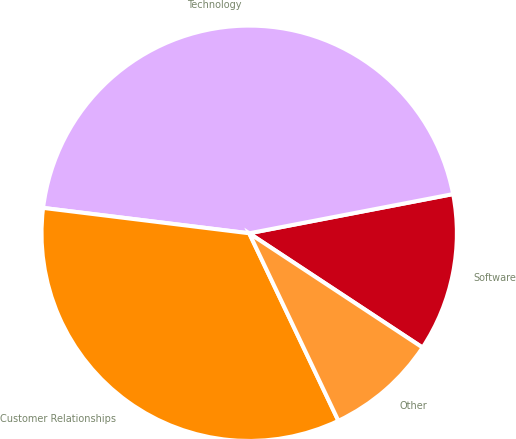Convert chart. <chart><loc_0><loc_0><loc_500><loc_500><pie_chart><fcel>Software<fcel>Technology<fcel>Customer Relationships<fcel>Other<nl><fcel>12.3%<fcel>45.03%<fcel>34.02%<fcel>8.66%<nl></chart> 